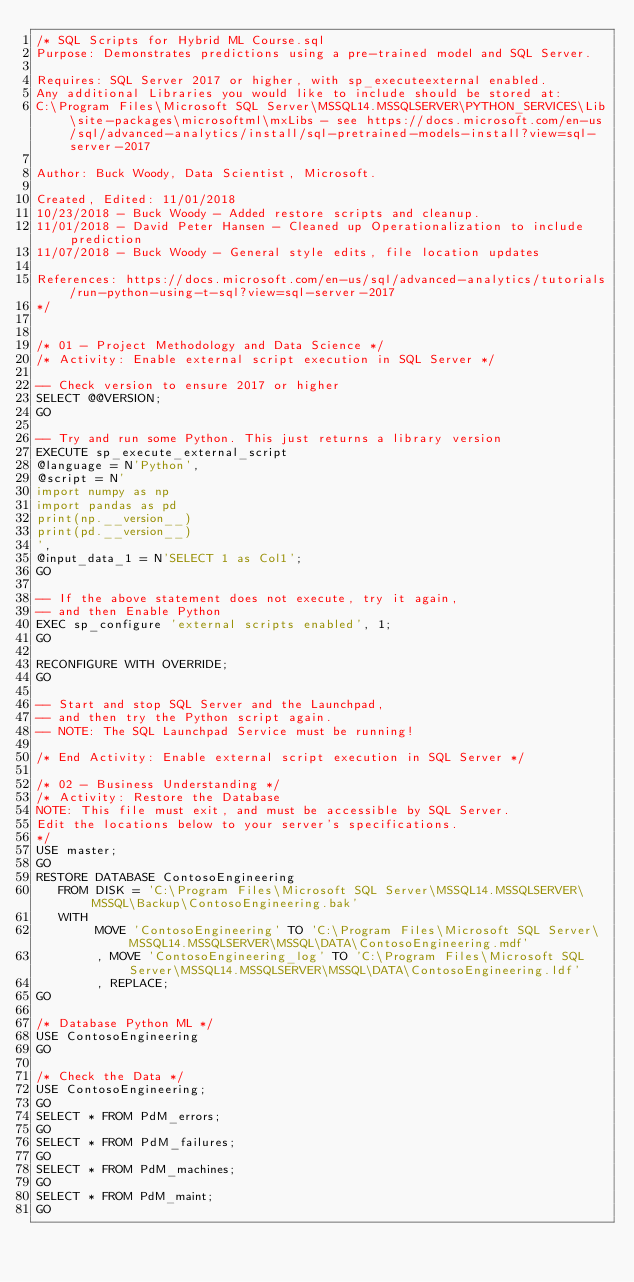Convert code to text. <code><loc_0><loc_0><loc_500><loc_500><_SQL_>/* SQL Scripts for Hybrid ML Course.sql
Purpose: Demonstrates predictions using a pre-trained model and SQL Server.

Requires: SQL Server 2017 or higher, with sp_executeexternal enabled.
Any additional Libraries you would like to include should be stored at:
C:\Program Files\Microsoft SQL Server\MSSQL14.MSSQLSERVER\PYTHON_SERVICES\Lib\site-packages\microsoftml\mxLibs - see https://docs.microsoft.com/en-us/sql/advanced-analytics/install/sql-pretrained-models-install?view=sql-server-2017

Author: Buck Woody, Data Scientist, Microsoft.

Created, Edited: 11/01/2018
10/23/2018 - Buck Woody - Added restore scripts and cleanup.
11/01/2018 - David Peter Hansen - Cleaned up Operationalization to include prediction
11/07/2018 - Buck Woody - General style edits, file location updates

References: https://docs.microsoft.com/en-us/sql/advanced-analytics/tutorials/run-python-using-t-sql?view=sql-server-2017
*/


/* 01 - Project Methodology and Data Science */
/* Activity: Enable external script execution in SQL Server */

-- Check version to ensure 2017 or higher
SELECT @@VERSION;
GO

-- Try and run some Python. This just returns a library version
EXECUTE sp_execute_external_script
@language = N'Python',
@script = N'
import numpy as np
import pandas as pd
print(np.__version__)
print(pd.__version__)
',
@input_data_1 = N'SELECT 1 as Col1';
GO

-- If the above statement does not execute, try it again,
-- and then Enable Python
EXEC sp_configure 'external scripts enabled', 1;
GO

RECONFIGURE WITH OVERRIDE;
GO

-- Start and stop SQL Server and the Launchpad,
-- and then try the Python script again.
-- NOTE: The SQL Launchpad Service must be running!

/* End Activity: Enable external script execution in SQL Server */

/* 02 - Business Understanding */
/* Activity: Restore the Database
NOTE: This file must exit, and must be accessible by SQL Server.
Edit the locations below to your server's specifications.
*/
USE master;
GO
RESTORE DATABASE ContosoEngineering
   FROM DISK = 'C:\Program Files\Microsoft SQL Server\MSSQL14.MSSQLSERVER\MSSQL\Backup\ContosoEngineering.bak'
   WITH
        MOVE 'ContosoEngineering' TO 'C:\Program Files\Microsoft SQL Server\MSSQL14.MSSQLSERVER\MSSQL\DATA\ContosoEngineering.mdf'
        , MOVE 'ContosoEngineering_log' TO 'C:\Program Files\Microsoft SQL Server\MSSQL14.MSSQLSERVER\MSSQL\DATA\ContosoEngineering.ldf'
		, REPLACE;
GO

/* Database Python ML */
USE ContosoEngineering
GO

/* Check the Data */
USE ContosoEngineering;
GO
SELECT * FROM PdM_errors;
GO
SELECT * FROM PdM_failures;
GO
SELECT * FROM PdM_machines;
GO
SELECT * FROM PdM_maint;
GO</code> 